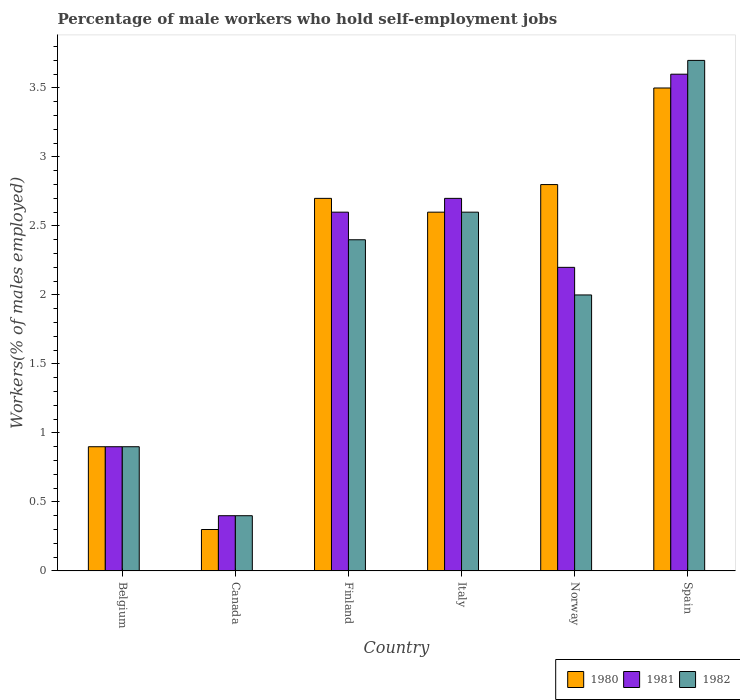How many different coloured bars are there?
Your answer should be compact. 3. How many groups of bars are there?
Your answer should be very brief. 6. Are the number of bars on each tick of the X-axis equal?
Your answer should be compact. Yes. What is the percentage of self-employed male workers in 1981 in Canada?
Your answer should be compact. 0.4. Across all countries, what is the minimum percentage of self-employed male workers in 1981?
Offer a terse response. 0.4. In which country was the percentage of self-employed male workers in 1982 minimum?
Your answer should be very brief. Canada. What is the total percentage of self-employed male workers in 1980 in the graph?
Your response must be concise. 12.8. What is the difference between the percentage of self-employed male workers in 1980 in Finland and that in Norway?
Give a very brief answer. -0.1. What is the difference between the percentage of self-employed male workers in 1981 in Canada and the percentage of self-employed male workers in 1980 in Belgium?
Ensure brevity in your answer.  -0.5. What is the average percentage of self-employed male workers in 1982 per country?
Keep it short and to the point. 2. What is the difference between the percentage of self-employed male workers of/in 1982 and percentage of self-employed male workers of/in 1981 in Spain?
Your response must be concise. 0.1. What is the ratio of the percentage of self-employed male workers in 1980 in Canada to that in Spain?
Offer a very short reply. 0.09. Is the percentage of self-employed male workers in 1980 in Canada less than that in Finland?
Offer a terse response. Yes. What is the difference between the highest and the second highest percentage of self-employed male workers in 1982?
Provide a succinct answer. -1.1. What is the difference between the highest and the lowest percentage of self-employed male workers in 1982?
Your response must be concise. 3.3. What does the 2nd bar from the left in Finland represents?
Offer a terse response. 1981. Is it the case that in every country, the sum of the percentage of self-employed male workers in 1982 and percentage of self-employed male workers in 1981 is greater than the percentage of self-employed male workers in 1980?
Make the answer very short. Yes. Does the graph contain any zero values?
Ensure brevity in your answer.  No. Where does the legend appear in the graph?
Your answer should be compact. Bottom right. How many legend labels are there?
Your response must be concise. 3. How are the legend labels stacked?
Provide a short and direct response. Horizontal. What is the title of the graph?
Provide a short and direct response. Percentage of male workers who hold self-employment jobs. Does "1978" appear as one of the legend labels in the graph?
Make the answer very short. No. What is the label or title of the Y-axis?
Your response must be concise. Workers(% of males employed). What is the Workers(% of males employed) of 1980 in Belgium?
Keep it short and to the point. 0.9. What is the Workers(% of males employed) in 1981 in Belgium?
Provide a succinct answer. 0.9. What is the Workers(% of males employed) of 1982 in Belgium?
Your answer should be very brief. 0.9. What is the Workers(% of males employed) in 1980 in Canada?
Keep it short and to the point. 0.3. What is the Workers(% of males employed) in 1981 in Canada?
Offer a terse response. 0.4. What is the Workers(% of males employed) in 1982 in Canada?
Your answer should be compact. 0.4. What is the Workers(% of males employed) in 1980 in Finland?
Your answer should be very brief. 2.7. What is the Workers(% of males employed) in 1981 in Finland?
Offer a terse response. 2.6. What is the Workers(% of males employed) of 1982 in Finland?
Offer a terse response. 2.4. What is the Workers(% of males employed) in 1980 in Italy?
Make the answer very short. 2.6. What is the Workers(% of males employed) in 1981 in Italy?
Make the answer very short. 2.7. What is the Workers(% of males employed) in 1982 in Italy?
Provide a succinct answer. 2.6. What is the Workers(% of males employed) of 1980 in Norway?
Provide a succinct answer. 2.8. What is the Workers(% of males employed) in 1981 in Norway?
Provide a short and direct response. 2.2. What is the Workers(% of males employed) in 1980 in Spain?
Your response must be concise. 3.5. What is the Workers(% of males employed) of 1981 in Spain?
Offer a very short reply. 3.6. What is the Workers(% of males employed) in 1982 in Spain?
Give a very brief answer. 3.7. Across all countries, what is the maximum Workers(% of males employed) in 1980?
Your answer should be compact. 3.5. Across all countries, what is the maximum Workers(% of males employed) of 1981?
Keep it short and to the point. 3.6. Across all countries, what is the maximum Workers(% of males employed) of 1982?
Ensure brevity in your answer.  3.7. Across all countries, what is the minimum Workers(% of males employed) in 1980?
Your response must be concise. 0.3. Across all countries, what is the minimum Workers(% of males employed) in 1981?
Give a very brief answer. 0.4. Across all countries, what is the minimum Workers(% of males employed) in 1982?
Make the answer very short. 0.4. What is the total Workers(% of males employed) in 1980 in the graph?
Offer a terse response. 12.8. What is the difference between the Workers(% of males employed) of 1980 in Belgium and that in Canada?
Offer a very short reply. 0.6. What is the difference between the Workers(% of males employed) in 1981 in Belgium and that in Canada?
Offer a very short reply. 0.5. What is the difference between the Workers(% of males employed) of 1980 in Belgium and that in Italy?
Make the answer very short. -1.7. What is the difference between the Workers(% of males employed) of 1982 in Belgium and that in Italy?
Offer a very short reply. -1.7. What is the difference between the Workers(% of males employed) in 1980 in Belgium and that in Norway?
Your answer should be very brief. -1.9. What is the difference between the Workers(% of males employed) in 1982 in Belgium and that in Norway?
Offer a terse response. -1.1. What is the difference between the Workers(% of males employed) in 1982 in Belgium and that in Spain?
Provide a succinct answer. -2.8. What is the difference between the Workers(% of males employed) of 1980 in Canada and that in Finland?
Your response must be concise. -2.4. What is the difference between the Workers(% of males employed) in 1981 in Canada and that in Finland?
Offer a terse response. -2.2. What is the difference between the Workers(% of males employed) in 1980 in Canada and that in Italy?
Your answer should be very brief. -2.3. What is the difference between the Workers(% of males employed) of 1981 in Canada and that in Italy?
Ensure brevity in your answer.  -2.3. What is the difference between the Workers(% of males employed) in 1980 in Canada and that in Norway?
Ensure brevity in your answer.  -2.5. What is the difference between the Workers(% of males employed) of 1982 in Canada and that in Norway?
Offer a very short reply. -1.6. What is the difference between the Workers(% of males employed) of 1981 in Canada and that in Spain?
Your answer should be very brief. -3.2. What is the difference between the Workers(% of males employed) of 1980 in Finland and that in Italy?
Give a very brief answer. 0.1. What is the difference between the Workers(% of males employed) in 1981 in Finland and that in Italy?
Provide a short and direct response. -0.1. What is the difference between the Workers(% of males employed) in 1982 in Finland and that in Italy?
Make the answer very short. -0.2. What is the difference between the Workers(% of males employed) of 1981 in Finland and that in Norway?
Provide a short and direct response. 0.4. What is the difference between the Workers(% of males employed) in 1982 in Finland and that in Norway?
Provide a succinct answer. 0.4. What is the difference between the Workers(% of males employed) of 1982 in Italy and that in Norway?
Your answer should be compact. 0.6. What is the difference between the Workers(% of males employed) in 1981 in Italy and that in Spain?
Make the answer very short. -0.9. What is the difference between the Workers(% of males employed) in 1982 in Italy and that in Spain?
Ensure brevity in your answer.  -1.1. What is the difference between the Workers(% of males employed) in 1981 in Norway and that in Spain?
Your answer should be compact. -1.4. What is the difference between the Workers(% of males employed) of 1980 in Belgium and the Workers(% of males employed) of 1981 in Canada?
Your response must be concise. 0.5. What is the difference between the Workers(% of males employed) of 1980 in Belgium and the Workers(% of males employed) of 1982 in Canada?
Keep it short and to the point. 0.5. What is the difference between the Workers(% of males employed) in 1981 in Belgium and the Workers(% of males employed) in 1982 in Finland?
Offer a very short reply. -1.5. What is the difference between the Workers(% of males employed) of 1980 in Belgium and the Workers(% of males employed) of 1982 in Italy?
Your response must be concise. -1.7. What is the difference between the Workers(% of males employed) in 1981 in Belgium and the Workers(% of males employed) in 1982 in Italy?
Keep it short and to the point. -1.7. What is the difference between the Workers(% of males employed) of 1981 in Belgium and the Workers(% of males employed) of 1982 in Norway?
Offer a terse response. -1.1. What is the difference between the Workers(% of males employed) of 1980 in Belgium and the Workers(% of males employed) of 1981 in Spain?
Give a very brief answer. -2.7. What is the difference between the Workers(% of males employed) in 1980 in Belgium and the Workers(% of males employed) in 1982 in Spain?
Give a very brief answer. -2.8. What is the difference between the Workers(% of males employed) in 1980 in Canada and the Workers(% of males employed) in 1982 in Finland?
Offer a terse response. -2.1. What is the difference between the Workers(% of males employed) in 1981 in Canada and the Workers(% of males employed) in 1982 in Finland?
Provide a succinct answer. -2. What is the difference between the Workers(% of males employed) in 1981 in Canada and the Workers(% of males employed) in 1982 in Italy?
Keep it short and to the point. -2.2. What is the difference between the Workers(% of males employed) in 1980 in Canada and the Workers(% of males employed) in 1982 in Norway?
Your response must be concise. -1.7. What is the difference between the Workers(% of males employed) of 1980 in Canada and the Workers(% of males employed) of 1981 in Spain?
Provide a short and direct response. -3.3. What is the difference between the Workers(% of males employed) of 1980 in Finland and the Workers(% of males employed) of 1981 in Italy?
Make the answer very short. 0. What is the difference between the Workers(% of males employed) in 1981 in Finland and the Workers(% of males employed) in 1982 in Italy?
Your answer should be very brief. 0. What is the difference between the Workers(% of males employed) of 1980 in Finland and the Workers(% of males employed) of 1981 in Norway?
Provide a succinct answer. 0.5. What is the difference between the Workers(% of males employed) of 1981 in Finland and the Workers(% of males employed) of 1982 in Spain?
Your answer should be very brief. -1.1. What is the difference between the Workers(% of males employed) of 1980 in Italy and the Workers(% of males employed) of 1981 in Norway?
Your response must be concise. 0.4. What is the difference between the Workers(% of males employed) of 1980 in Norway and the Workers(% of males employed) of 1981 in Spain?
Give a very brief answer. -0.8. What is the difference between the Workers(% of males employed) of 1980 in Norway and the Workers(% of males employed) of 1982 in Spain?
Ensure brevity in your answer.  -0.9. What is the difference between the Workers(% of males employed) of 1981 in Norway and the Workers(% of males employed) of 1982 in Spain?
Offer a terse response. -1.5. What is the average Workers(% of males employed) in 1980 per country?
Your answer should be compact. 2.13. What is the average Workers(% of males employed) of 1981 per country?
Your answer should be compact. 2.07. What is the difference between the Workers(% of males employed) of 1980 and Workers(% of males employed) of 1981 in Belgium?
Give a very brief answer. 0. What is the difference between the Workers(% of males employed) of 1981 and Workers(% of males employed) of 1982 in Belgium?
Your answer should be compact. 0. What is the difference between the Workers(% of males employed) of 1980 and Workers(% of males employed) of 1982 in Canada?
Give a very brief answer. -0.1. What is the difference between the Workers(% of males employed) of 1980 and Workers(% of males employed) of 1982 in Norway?
Provide a succinct answer. 0.8. What is the difference between the Workers(% of males employed) in 1981 and Workers(% of males employed) in 1982 in Norway?
Provide a succinct answer. 0.2. What is the difference between the Workers(% of males employed) of 1981 and Workers(% of males employed) of 1982 in Spain?
Ensure brevity in your answer.  -0.1. What is the ratio of the Workers(% of males employed) of 1981 in Belgium to that in Canada?
Give a very brief answer. 2.25. What is the ratio of the Workers(% of males employed) in 1982 in Belgium to that in Canada?
Your response must be concise. 2.25. What is the ratio of the Workers(% of males employed) in 1980 in Belgium to that in Finland?
Offer a terse response. 0.33. What is the ratio of the Workers(% of males employed) in 1981 in Belgium to that in Finland?
Keep it short and to the point. 0.35. What is the ratio of the Workers(% of males employed) in 1980 in Belgium to that in Italy?
Your answer should be compact. 0.35. What is the ratio of the Workers(% of males employed) in 1981 in Belgium to that in Italy?
Provide a succinct answer. 0.33. What is the ratio of the Workers(% of males employed) in 1982 in Belgium to that in Italy?
Provide a succinct answer. 0.35. What is the ratio of the Workers(% of males employed) of 1980 in Belgium to that in Norway?
Ensure brevity in your answer.  0.32. What is the ratio of the Workers(% of males employed) in 1981 in Belgium to that in Norway?
Provide a short and direct response. 0.41. What is the ratio of the Workers(% of males employed) in 1982 in Belgium to that in Norway?
Provide a succinct answer. 0.45. What is the ratio of the Workers(% of males employed) of 1980 in Belgium to that in Spain?
Your answer should be very brief. 0.26. What is the ratio of the Workers(% of males employed) of 1981 in Belgium to that in Spain?
Give a very brief answer. 0.25. What is the ratio of the Workers(% of males employed) of 1982 in Belgium to that in Spain?
Ensure brevity in your answer.  0.24. What is the ratio of the Workers(% of males employed) of 1981 in Canada to that in Finland?
Your answer should be very brief. 0.15. What is the ratio of the Workers(% of males employed) of 1982 in Canada to that in Finland?
Offer a terse response. 0.17. What is the ratio of the Workers(% of males employed) in 1980 in Canada to that in Italy?
Provide a short and direct response. 0.12. What is the ratio of the Workers(% of males employed) in 1981 in Canada to that in Italy?
Provide a short and direct response. 0.15. What is the ratio of the Workers(% of males employed) of 1982 in Canada to that in Italy?
Your answer should be compact. 0.15. What is the ratio of the Workers(% of males employed) in 1980 in Canada to that in Norway?
Keep it short and to the point. 0.11. What is the ratio of the Workers(% of males employed) in 1981 in Canada to that in Norway?
Give a very brief answer. 0.18. What is the ratio of the Workers(% of males employed) in 1980 in Canada to that in Spain?
Your answer should be very brief. 0.09. What is the ratio of the Workers(% of males employed) of 1982 in Canada to that in Spain?
Your answer should be very brief. 0.11. What is the ratio of the Workers(% of males employed) in 1980 in Finland to that in Italy?
Your answer should be compact. 1.04. What is the ratio of the Workers(% of males employed) in 1981 in Finland to that in Italy?
Offer a very short reply. 0.96. What is the ratio of the Workers(% of males employed) in 1980 in Finland to that in Norway?
Provide a short and direct response. 0.96. What is the ratio of the Workers(% of males employed) of 1981 in Finland to that in Norway?
Provide a succinct answer. 1.18. What is the ratio of the Workers(% of males employed) of 1982 in Finland to that in Norway?
Keep it short and to the point. 1.2. What is the ratio of the Workers(% of males employed) of 1980 in Finland to that in Spain?
Keep it short and to the point. 0.77. What is the ratio of the Workers(% of males employed) in 1981 in Finland to that in Spain?
Provide a short and direct response. 0.72. What is the ratio of the Workers(% of males employed) in 1982 in Finland to that in Spain?
Make the answer very short. 0.65. What is the ratio of the Workers(% of males employed) of 1981 in Italy to that in Norway?
Give a very brief answer. 1.23. What is the ratio of the Workers(% of males employed) in 1980 in Italy to that in Spain?
Give a very brief answer. 0.74. What is the ratio of the Workers(% of males employed) in 1981 in Italy to that in Spain?
Give a very brief answer. 0.75. What is the ratio of the Workers(% of males employed) of 1982 in Italy to that in Spain?
Your response must be concise. 0.7. What is the ratio of the Workers(% of males employed) of 1981 in Norway to that in Spain?
Keep it short and to the point. 0.61. What is the ratio of the Workers(% of males employed) in 1982 in Norway to that in Spain?
Provide a succinct answer. 0.54. What is the difference between the highest and the second highest Workers(% of males employed) of 1980?
Your response must be concise. 0.7. What is the difference between the highest and the second highest Workers(% of males employed) of 1981?
Your answer should be compact. 0.9. What is the difference between the highest and the second highest Workers(% of males employed) of 1982?
Provide a short and direct response. 1.1. 